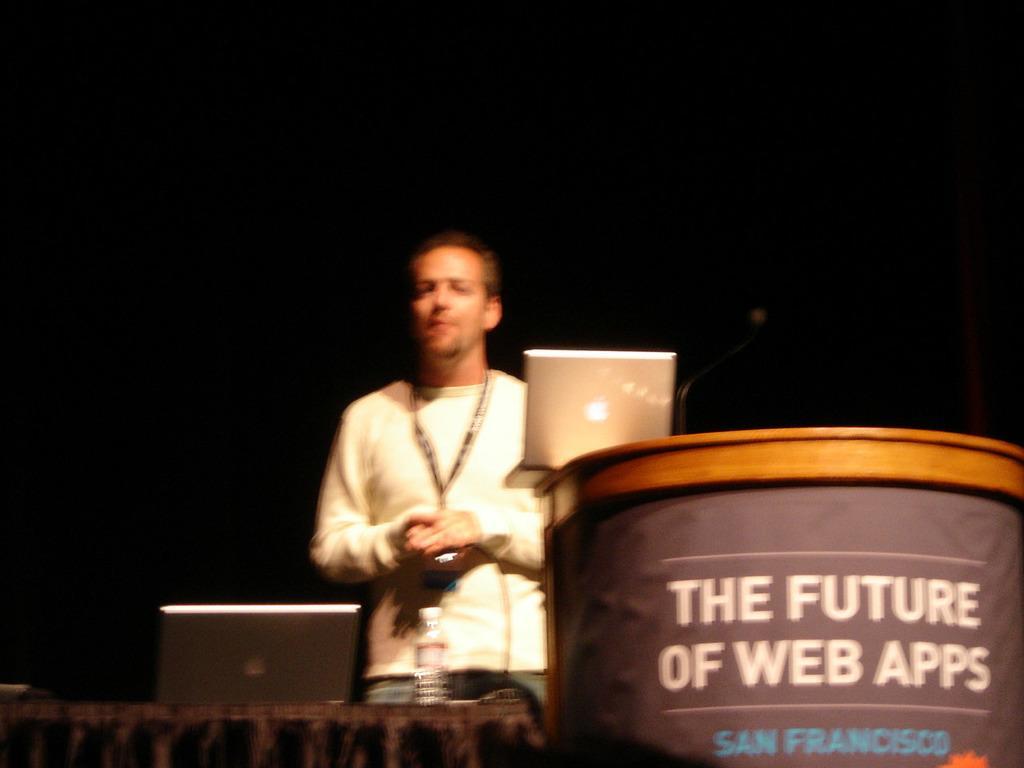Could you give a brief overview of what you see in this image? In this image we can see a person wearing a white shirt is standing in front of a table on which a laptop and a bottle is placed. To the right side of the image we can see a podium on which a microphone and a laptop are placed. 